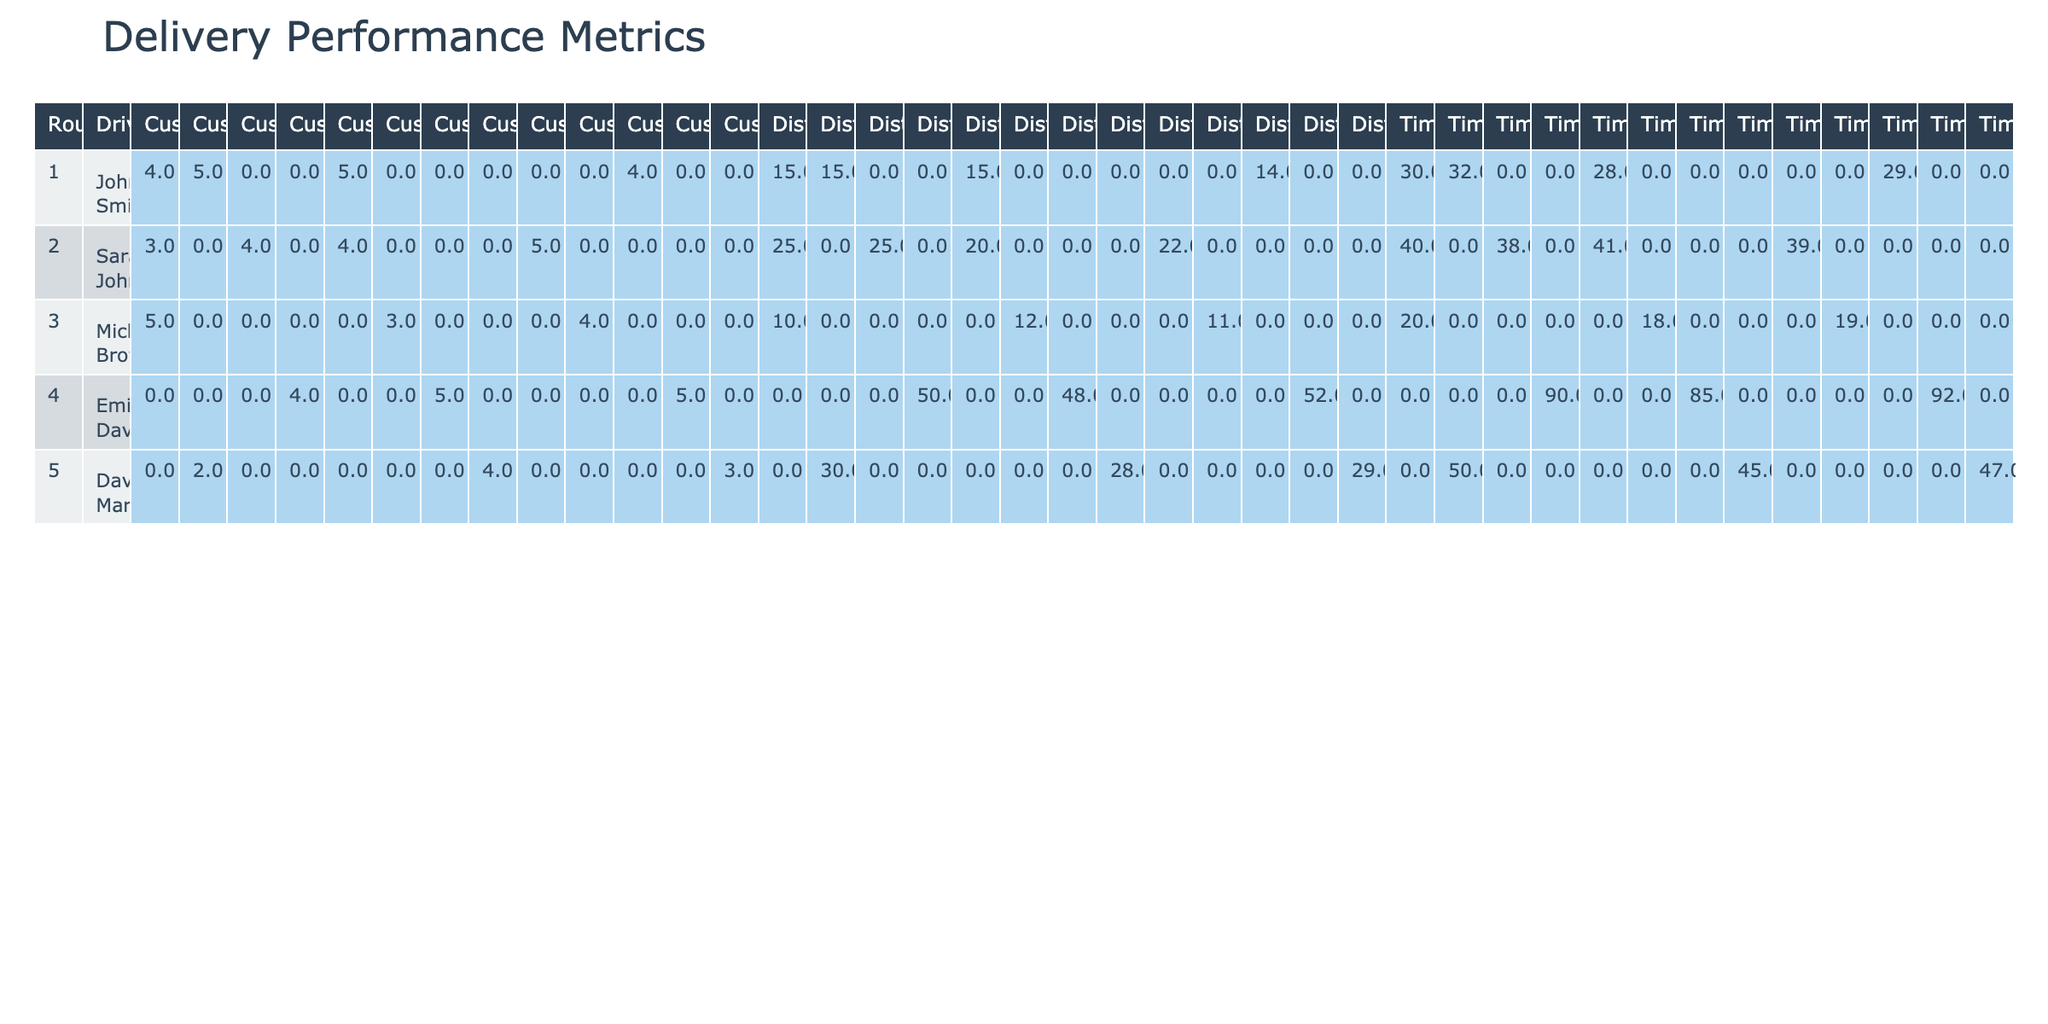What is the distance covered by John Smith on October 5, 2023? From the table, under John Smith in the DeliveryDate column for 2023-10-05, the Distance_km value is 15.
Answer: 15 What was the delivery status of the route taken by David Martinez on October 8, 2023? Looking at the table, the DeliveryStatus for David Martinez on 2023-10-08 is marked as "Completed."
Answer: Completed On which date did Sarah Johnson have her shortest delivery time, and how long was it? By examining Sarah Johnson's entries, the shortest Time_taken_minutes is 38 on October 3, 2023.
Answer: October 3, 38 minutes What is the average customer satisfaction rating for all deliveries made by Emily Davis? To find the average, we add her CustomerSatisfaction values (4 + 5) and divide by 2: (4 + 5)/2 = 4.5.
Answer: 4.5 Were there any cancelled deliveries made by Michael Brown? Looking at Michael Brown's entries, both have a DeliveryStatus of "Completed," indicating he had no cancellations.
Answer: No What is the total distance covered by Sarah Johnson across all her deliveries? Adding Sarah Johnson’s distances: 25 + 25 + 20 + 22 = 92 km.
Answer: 92 km Did any driver complete a delivery on October 10, 2023? Checking the table for October 10, 2023, Michael Brown's delivery status is "Completed," confirming a delivery was made.
Answer: Yes What is the difference in time taken for Emily Davis's deliveries on October 4 and October 12, 2023? Emily's time on October 4 is 90 minutes, and on October 12 is 92 minutes. The difference is 92 - 90 = 2 minutes.
Answer: 2 minutes Who had the highest customer satisfaction score, and what was the score? Michael Brown has multiple scores with a high score being 5 on October 1, 2023, which is the maximum.
Answer: Michael Brown, 5 What is the total amount of time taken by David Martinez for completed deliveries? David's completed deliveries on October 8 took 45 minutes. His cancelled delivery on October 2 is not included.
Answer: 45 minutes 